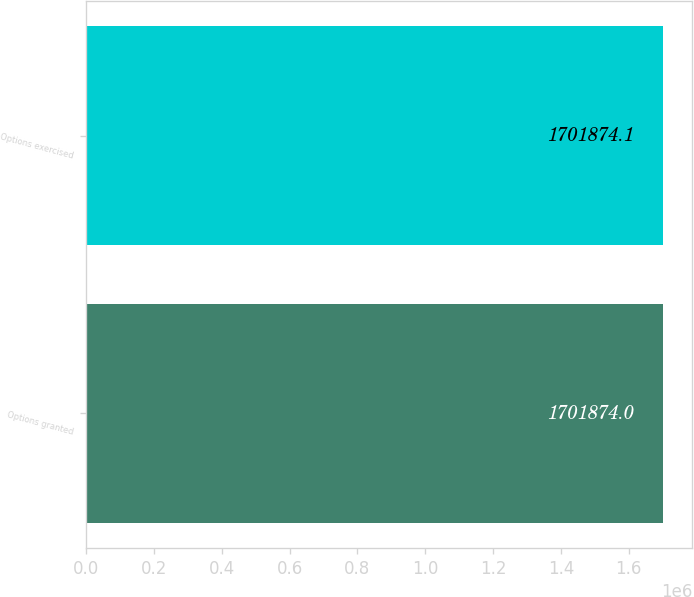<chart> <loc_0><loc_0><loc_500><loc_500><bar_chart><fcel>Options granted<fcel>Options exercised<nl><fcel>1.70187e+06<fcel>1.70187e+06<nl></chart> 